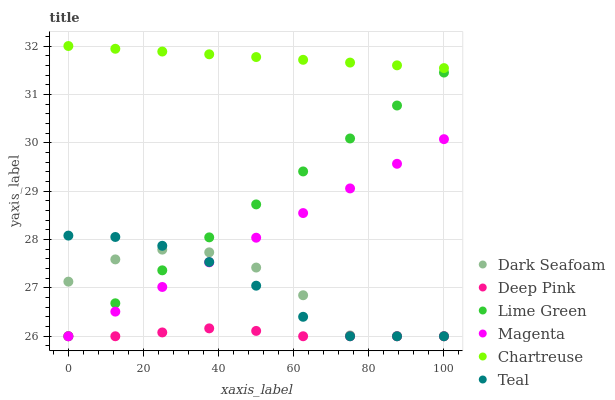Does Deep Pink have the minimum area under the curve?
Answer yes or no. Yes. Does Chartreuse have the maximum area under the curve?
Answer yes or no. Yes. Does Dark Seafoam have the minimum area under the curve?
Answer yes or no. No. Does Dark Seafoam have the maximum area under the curve?
Answer yes or no. No. Is Magenta the smoothest?
Answer yes or no. Yes. Is Dark Seafoam the roughest?
Answer yes or no. Yes. Is Chartreuse the smoothest?
Answer yes or no. No. Is Chartreuse the roughest?
Answer yes or no. No. Does Deep Pink have the lowest value?
Answer yes or no. Yes. Does Chartreuse have the lowest value?
Answer yes or no. No. Does Chartreuse have the highest value?
Answer yes or no. Yes. Does Dark Seafoam have the highest value?
Answer yes or no. No. Is Deep Pink less than Chartreuse?
Answer yes or no. Yes. Is Chartreuse greater than Dark Seafoam?
Answer yes or no. Yes. Does Lime Green intersect Teal?
Answer yes or no. Yes. Is Lime Green less than Teal?
Answer yes or no. No. Is Lime Green greater than Teal?
Answer yes or no. No. Does Deep Pink intersect Chartreuse?
Answer yes or no. No. 